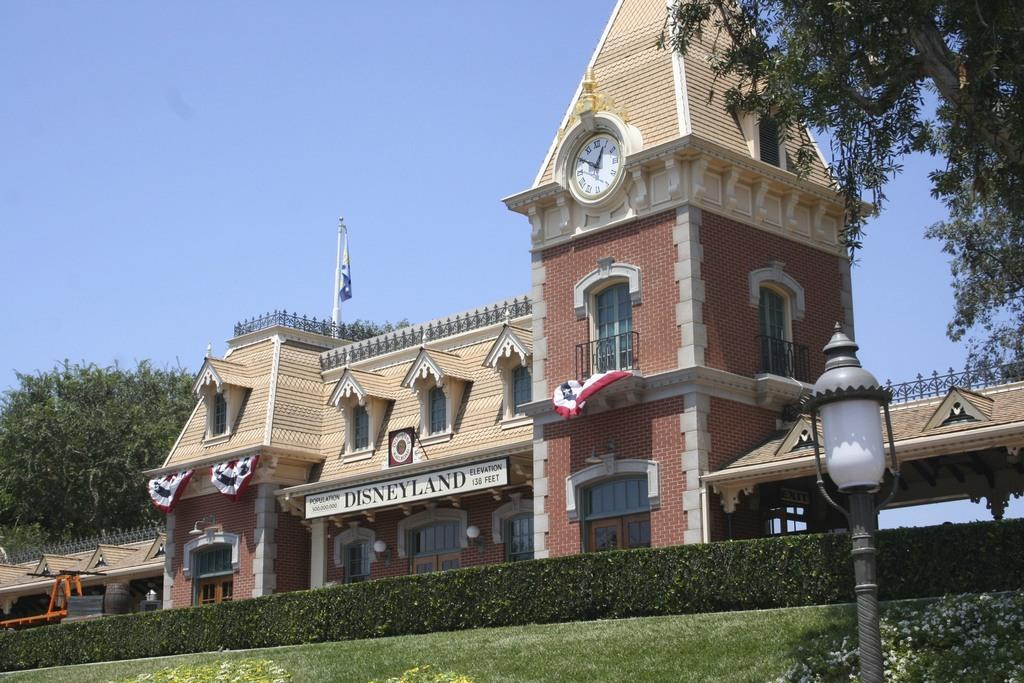<image>
Write a terse but informative summary of the picture. a building with a white sign on the front that says 'disneyland' 